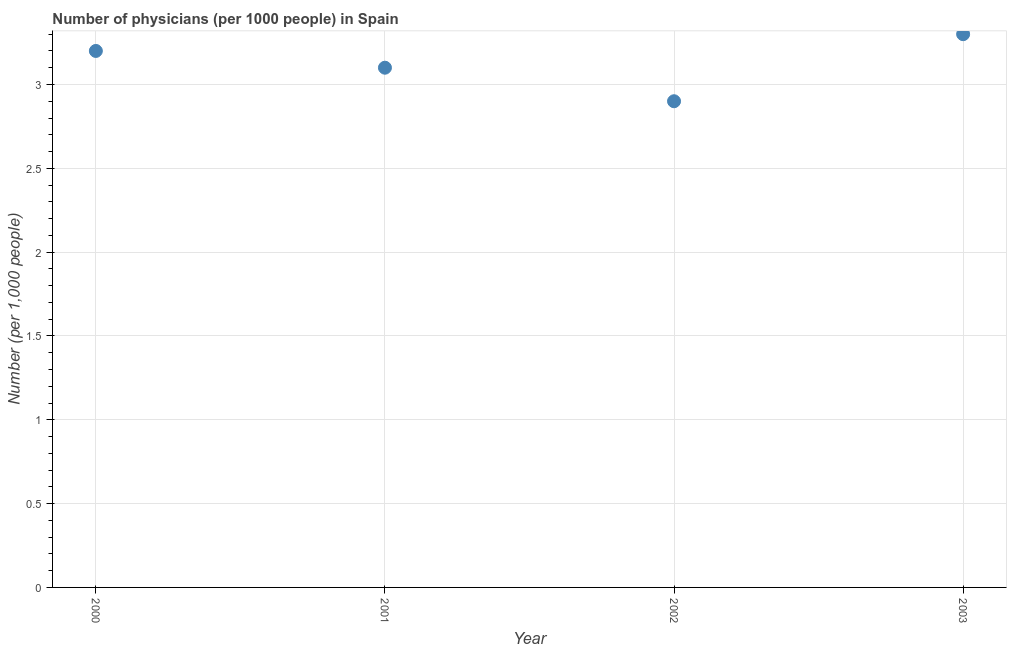What is the number of physicians in 2003?
Give a very brief answer. 3.3. Across all years, what is the maximum number of physicians?
Make the answer very short. 3.3. Across all years, what is the minimum number of physicians?
Offer a terse response. 2.9. In which year was the number of physicians maximum?
Offer a terse response. 2003. What is the sum of the number of physicians?
Provide a succinct answer. 12.5. What is the difference between the number of physicians in 2000 and 2002?
Your answer should be compact. 0.3. What is the average number of physicians per year?
Ensure brevity in your answer.  3.12. What is the median number of physicians?
Make the answer very short. 3.15. In how many years, is the number of physicians greater than 1.6 ?
Provide a succinct answer. 4. What is the ratio of the number of physicians in 2001 to that in 2003?
Keep it short and to the point. 0.94. Is the difference between the number of physicians in 2000 and 2001 greater than the difference between any two years?
Give a very brief answer. No. What is the difference between the highest and the second highest number of physicians?
Keep it short and to the point. 0.1. Is the sum of the number of physicians in 2002 and 2003 greater than the maximum number of physicians across all years?
Provide a succinct answer. Yes. What is the difference between the highest and the lowest number of physicians?
Offer a terse response. 0.4. Does the number of physicians monotonically increase over the years?
Provide a short and direct response. No. Does the graph contain any zero values?
Make the answer very short. No. Does the graph contain grids?
Your response must be concise. Yes. What is the title of the graph?
Give a very brief answer. Number of physicians (per 1000 people) in Spain. What is the label or title of the Y-axis?
Provide a succinct answer. Number (per 1,0 people). What is the Number (per 1,000 people) in 2001?
Offer a terse response. 3.1. What is the Number (per 1,000 people) in 2002?
Make the answer very short. 2.9. What is the Number (per 1,000 people) in 2003?
Your response must be concise. 3.3. What is the difference between the Number (per 1,000 people) in 2000 and 2001?
Provide a short and direct response. 0.1. What is the difference between the Number (per 1,000 people) in 2000 and 2002?
Your answer should be very brief. 0.3. What is the difference between the Number (per 1,000 people) in 2000 and 2003?
Provide a short and direct response. -0.1. What is the difference between the Number (per 1,000 people) in 2001 and 2002?
Offer a terse response. 0.2. What is the difference between the Number (per 1,000 people) in 2002 and 2003?
Keep it short and to the point. -0.4. What is the ratio of the Number (per 1,000 people) in 2000 to that in 2001?
Your response must be concise. 1.03. What is the ratio of the Number (per 1,000 people) in 2000 to that in 2002?
Offer a terse response. 1.1. What is the ratio of the Number (per 1,000 people) in 2001 to that in 2002?
Provide a succinct answer. 1.07. What is the ratio of the Number (per 1,000 people) in 2001 to that in 2003?
Keep it short and to the point. 0.94. What is the ratio of the Number (per 1,000 people) in 2002 to that in 2003?
Offer a terse response. 0.88. 